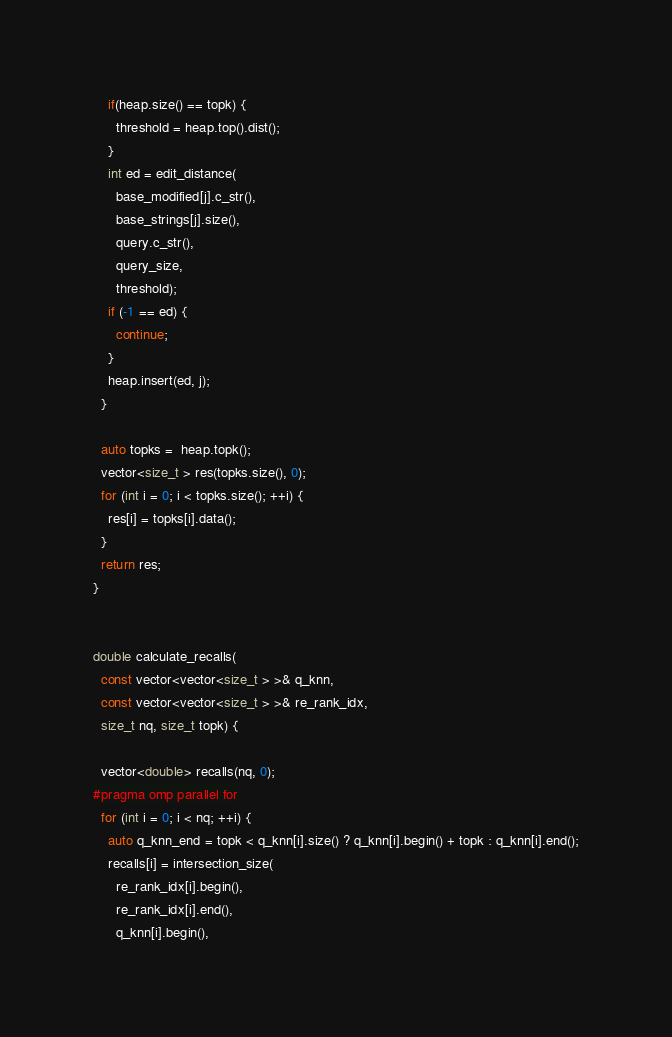<code> <loc_0><loc_0><loc_500><loc_500><_C_>    if(heap.size() == topk) {
      threshold = heap.top().dist();
    }
    int ed = edit_distance(
      base_modified[j].c_str(),
      base_strings[j].size(),
      query.c_str(),
      query_size,
      threshold);
    if (-1 == ed) {
      continue;
    }
    heap.insert(ed, j);
  }

  auto topks =  heap.topk();
  vector<size_t > res(topks.size(), 0);
  for (int i = 0; i < topks.size(); ++i) {
    res[i] = topks[i].data();
  }
  return res;
}


double calculate_recalls(
  const vector<vector<size_t > >& q_knn,
  const vector<vector<size_t > >& re_rank_idx,
  size_t nq, size_t topk) {

  vector<double> recalls(nq, 0);
#pragma omp parallel for
  for (int i = 0; i < nq; ++i) {
    auto q_knn_end = topk < q_knn[i].size() ? q_knn[i].begin() + topk : q_knn[i].end();
    recalls[i] = intersection_size(
      re_rank_idx[i].begin(),
      re_rank_idx[i].end(),
      q_knn[i].begin(),</code> 